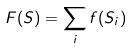Convert formula to latex. <formula><loc_0><loc_0><loc_500><loc_500>F ( S ) = \sum _ { i } f ( S _ { i } )</formula> 